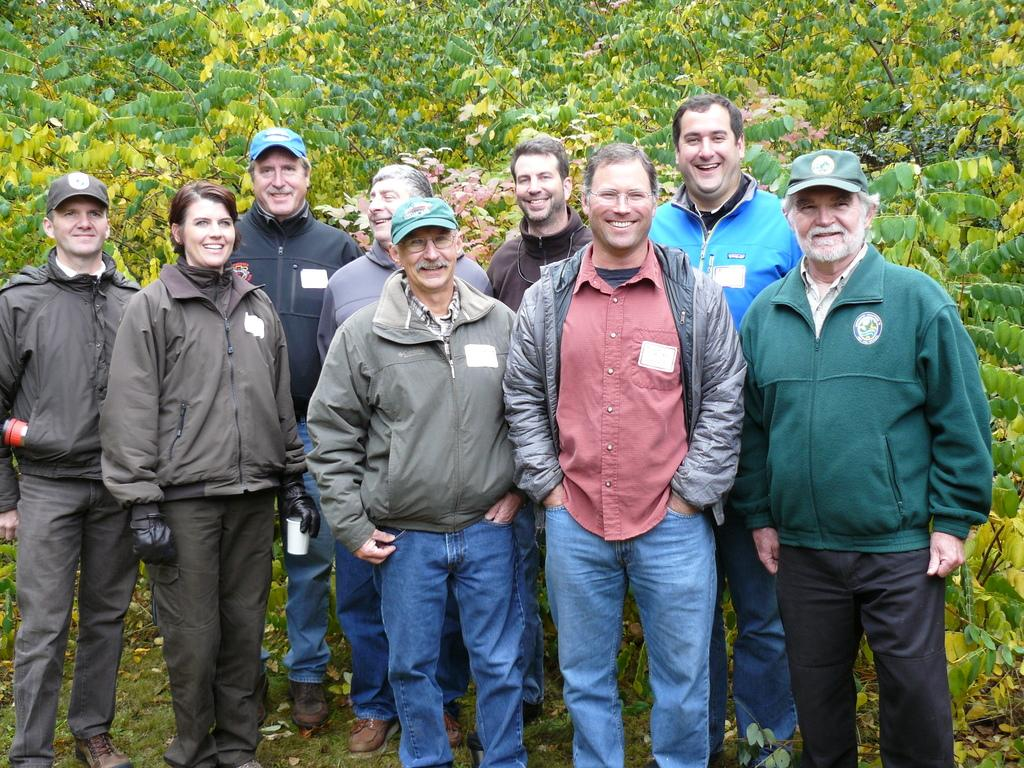How many people are in the image? There is a group of persons in the image. What are the persons in the image doing? The persons are standing and smiling. What can be seen in the background of the image? There are plants in the background of the image. What type of board can be seen in the image? There is no board present in the image. Can you describe the home where the persons are standing in the image? The image does not show a home; it only shows a group of persons standing with plants in the background. 